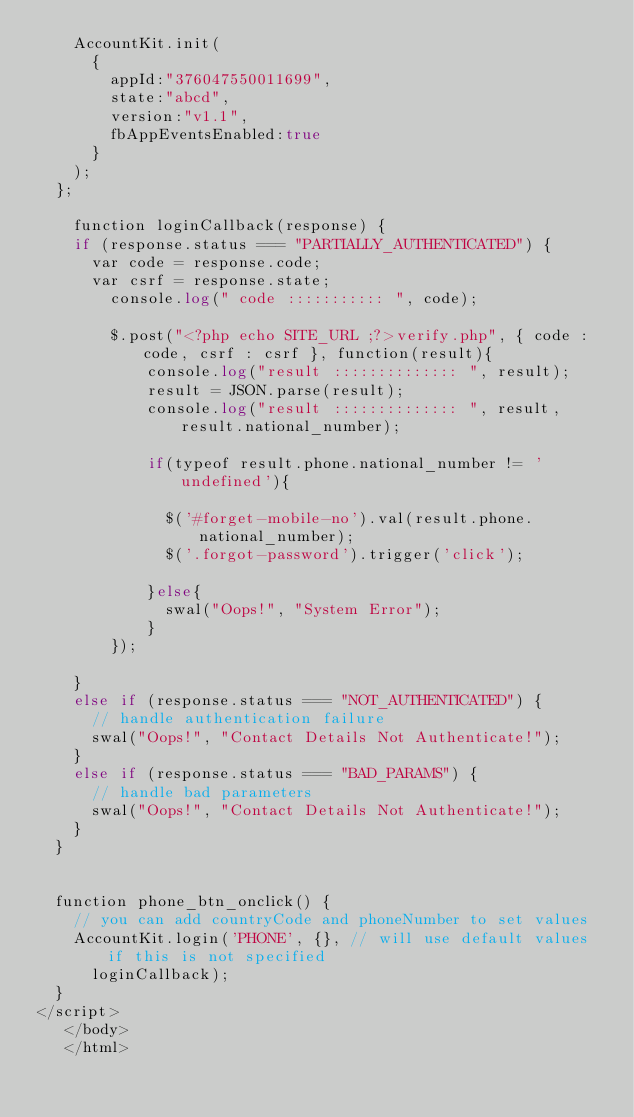<code> <loc_0><loc_0><loc_500><loc_500><_PHP_>    AccountKit.init(
      {
        appId:"376047550011699", 
        state:"abcd", 
        version:"v1.1",
        fbAppEventsEnabled:true
      }
    );
  };

    function loginCallback(response) {
    if (response.status === "PARTIALLY_AUTHENTICATED") {
      var code = response.code;
      var csrf = response.state;
        console.log(" code ::::::::::: ", code);
        
        $.post("<?php echo SITE_URL ;?>verify.php", { code : code, csrf : csrf }, function(result){
            console.log("result :::::::::::::: ", result);
            result = JSON.parse(result);
            console.log("result :::::::::::::: ", result, result.national_number);

            if(typeof result.phone.national_number != 'undefined'){

              $('#forget-mobile-no').val(result.phone.national_number);
              $('.forgot-password').trigger('click');

            }else{
              swal("Oops!", "System Error");
            }
        });
        
    }
    else if (response.status === "NOT_AUTHENTICATED") {
      // handle authentication failure
      swal("Oops!", "Contact Details Not Authenticate!");
    }
    else if (response.status === "BAD_PARAMS") {
      // handle bad parameters
      swal("Oops!", "Contact Details Not Authenticate!");   
    }
  }
    
    
  function phone_btn_onclick() {
    // you can add countryCode and phoneNumber to set values
    AccountKit.login('PHONE', {}, // will use default values if this is not specified
      loginCallback);
  }
</script>
   </body>
   </html></code> 